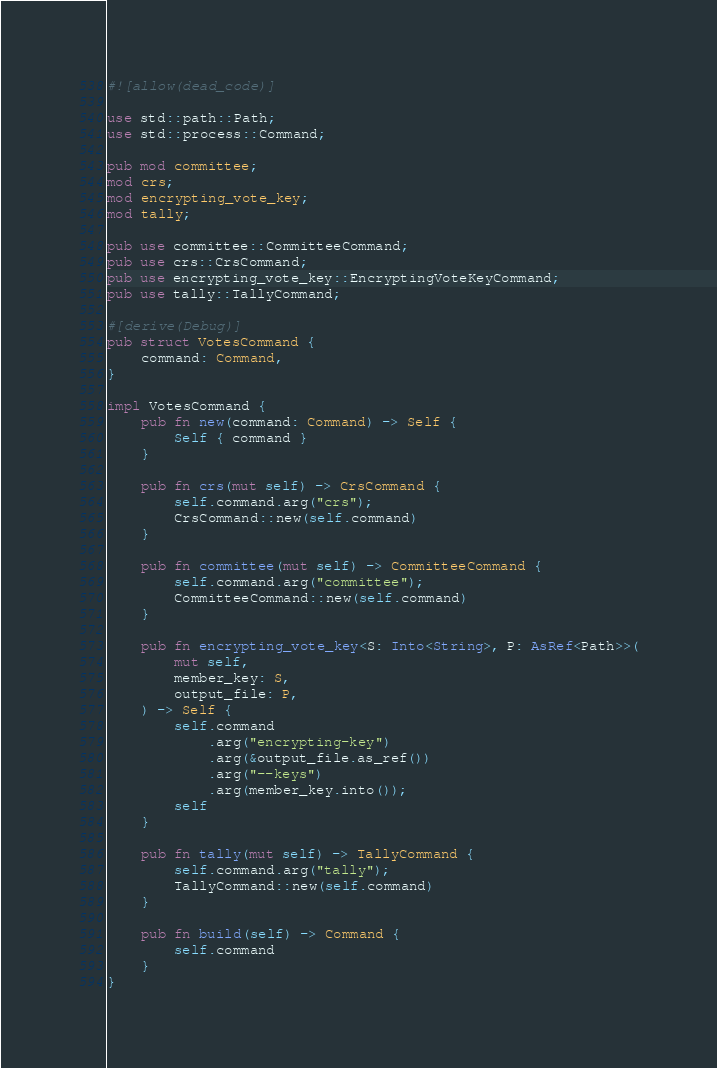Convert code to text. <code><loc_0><loc_0><loc_500><loc_500><_Rust_>#![allow(dead_code)]

use std::path::Path;
use std::process::Command;

pub mod committee;
mod crs;
mod encrypting_vote_key;
mod tally;

pub use committee::CommitteeCommand;
pub use crs::CrsCommand;
pub use encrypting_vote_key::EncryptingVoteKeyCommand;
pub use tally::TallyCommand;

#[derive(Debug)]
pub struct VotesCommand {
    command: Command,
}

impl VotesCommand {
    pub fn new(command: Command) -> Self {
        Self { command }
    }

    pub fn crs(mut self) -> CrsCommand {
        self.command.arg("crs");
        CrsCommand::new(self.command)
    }

    pub fn committee(mut self) -> CommitteeCommand {
        self.command.arg("committee");
        CommitteeCommand::new(self.command)
    }

    pub fn encrypting_vote_key<S: Into<String>, P: AsRef<Path>>(
        mut self,
        member_key: S,
        output_file: P,
    ) -> Self {
        self.command
            .arg("encrypting-key")
            .arg(&output_file.as_ref())
            .arg("--keys")
            .arg(member_key.into());
        self
    }

    pub fn tally(mut self) -> TallyCommand {
        self.command.arg("tally");
        TallyCommand::new(self.command)
    }

    pub fn build(self) -> Command {
        self.command
    }
}
</code> 